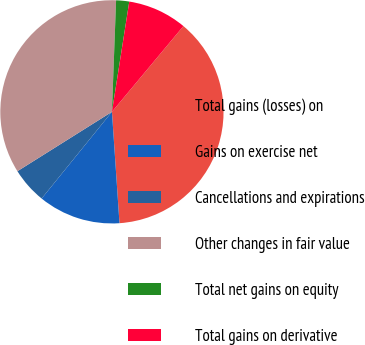Convert chart. <chart><loc_0><loc_0><loc_500><loc_500><pie_chart><fcel>Total gains (losses) on<fcel>Gains on exercise net<fcel>Cancellations and expirations<fcel>Other changes in fair value<fcel>Total net gains on equity<fcel>Total gains on derivative<nl><fcel>37.86%<fcel>11.92%<fcel>5.23%<fcel>34.52%<fcel>1.89%<fcel>8.58%<nl></chart> 